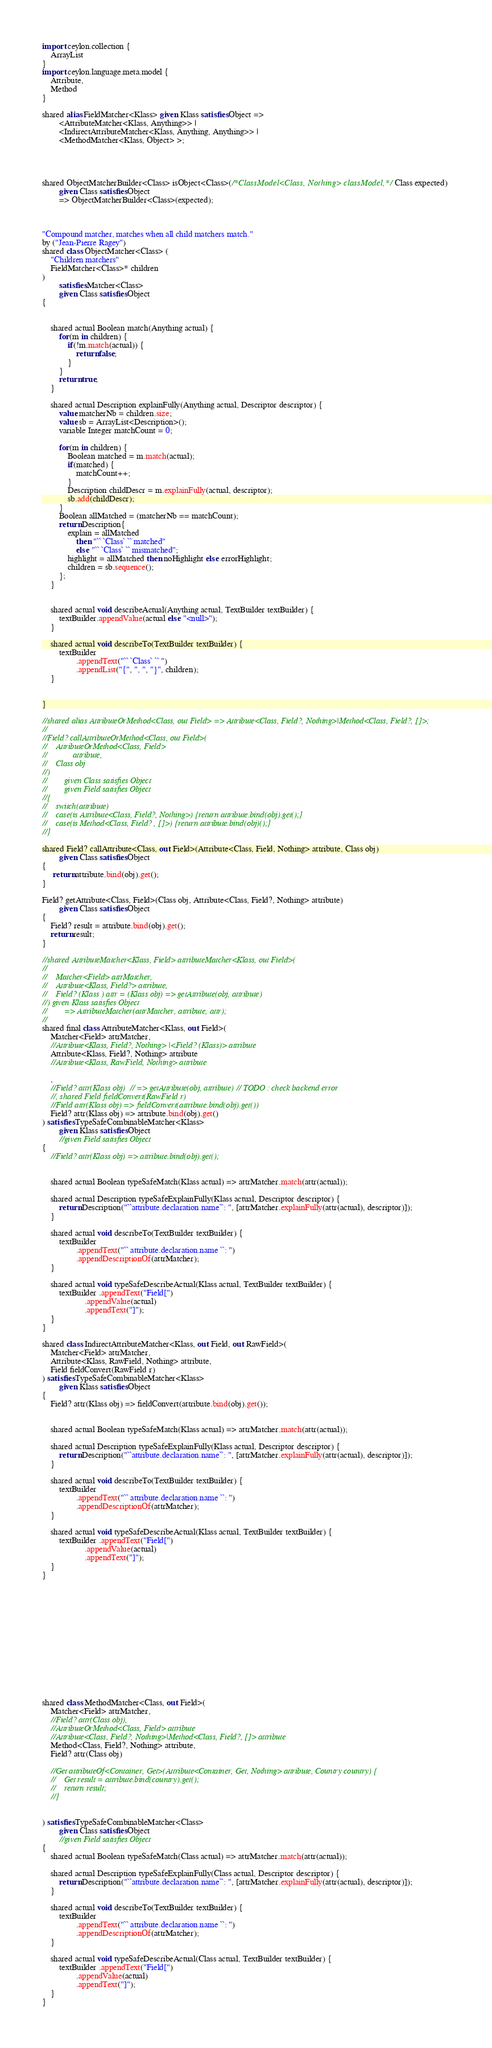Convert code to text. <code><loc_0><loc_0><loc_500><loc_500><_Ceylon_>import ceylon.collection {
	ArrayList
}
import ceylon.language.meta.model {
	Attribute,
	Method
}

shared alias FieldMatcher<Klass> given Klass satisfies Object => 
        <AttributeMatcher<Klass, Anything>> | 
        <IndirectAttributeMatcher<Klass, Anything, Anything>> | 
        <MethodMatcher<Klass, Object> >;




shared ObjectMatcherBuilder<Class> isObject<Class>(/*ClassModel<Class, Nothing> classModel,*/ Class expected) 
        given Class satisfies Object
        => ObjectMatcherBuilder<Class>(expected);



"Compound matcher, matches when all child matchers match."
by ("Jean-Pierre Ragey")
shared class ObjectMatcher<Class> (
    "Children matchers"
    FieldMatcher<Class>* children
) 
        satisfies Matcher<Class> 
        given Class satisfies Object
{
            
    
    shared actual Boolean match(Anything actual) {
        for(m in children) {
            if(!m.match(actual)) {
                return false;
            }
        }
        return true;
    }
    
    shared actual Description explainFully(Anything actual, Descriptor descriptor) {
        value matcherNb = children.size;
        value sb = ArrayList<Description>();
        variable Integer matchCount = 0;
        
        for(m in children) {
            Boolean matched = m.match(actual);
            if(matched) {
                matchCount++;
            }
            Description childDescr = m.explainFully(actual, descriptor);
            sb.add(childDescr);
        }
        Boolean allMatched = (matcherNb == matchCount);
        return Description{
            explain = allMatched
                then "`` `Class` `` matched"
                else "`` `Class` `` mismatched";
            highlight = allMatched then noHighlight else errorHighlight;
            children = sb.sequence();
        };
    }
    
    
    shared actual void describeActual(Anything actual, TextBuilder textBuilder) {
        textBuilder.appendValue(actual else "<null>");
    }
    
    shared actual void describeTo(TextBuilder textBuilder) {
        textBuilder
                .appendText("`` `Class` `` ")
                .appendList("{", ", ", "}", children);
    }
    
    
}

//shared alias AttributeOrMethod<Class, out Field> => Attribute<Class, Field?, Nothing>|Method<Class, Field?, []>;
//
//Field? callAttributeOrMethod<Class, out Field>(
//    AttributeOrMethod<Class, Field> 
//            attribute,
//    Class obj
//) 
//        given Class satisfies Object
//        given Field satisfies Object
//{
//    switch(attribute)
//    case(is Attribute<Class, Field?, Nothing>) {return attribute.bind(obj).get();}
//    case(is Method<Class, Field? , []>) {return attribute.bind(obj)();}
//}

shared Field? callAttribute<Class, out Field>(Attribute<Class, Field, Nothing> attribute, Class obj) 
        given Class satisfies Object
{
     return attribute.bind(obj).get();
}

Field? getAttribute<Class, Field>(Class obj, Attribute<Class, Field?, Nothing> attribute)
        given Class satisfies Object
{
    Field? result = attribute.bind(obj).get();
    return result;
}

//shared AttributeMatcher<Klass, Field> attributeMatcher<Klass, out Field>(
// 
//    Matcher<Field> attrMatcher, 
//    Attribute<Klass, Field?> attribute,
//    Field? (Klass ) attr = (Klass obj) => getAttribute(obj, attribute)
//) given Klass satisfies Object
//        => AttributeMatcher(attrMatcher, attribute, attr);
//
shared final class AttributeMatcher<Klass, out Field>(
    Matcher<Field> attrMatcher, 
    //Attribute<Klass, Field?, Nothing> |<Field? (Klass)> attribute
    Attribute<Klass, Field?, Nothing> attribute
    //Attribute<Klass, RawField, Nothing> attribute
    
    ,
    //Field? attr(Klass obj)  // => getAttribute(obj, attribute) // TODO : check backend error
    //, shared Field fieldConvert(RawField r)
    //Field attr(Klass obj) => fieldConvert(attribute.bind(obj).get())
    Field? attr(Klass obj) => attribute.bind(obj).get()
) satisfies TypeSafeCombinableMatcher<Klass>
        given Klass satisfies Object
        //given Field satisfies Object
{
    //Field? attr(Klass obj) => attribute.bind(obj).get();
    
    
    shared actual Boolean typeSafeMatch(Klass actual) => attrMatcher.match(attr(actual));

    shared actual Description typeSafeExplainFully(Klass actual, Descriptor descriptor) {
        return Description("``attribute.declaration.name``: ", [attrMatcher.explainFully(attr(actual), descriptor)]);
    }

    shared actual void describeTo(TextBuilder textBuilder) {
        textBuilder
                .appendText("`` attribute.declaration.name ``: ") 
                .appendDescriptionOf(attrMatcher);
    }
    
    shared actual void typeSafeDescribeActual(Klass actual, TextBuilder textBuilder) {
        textBuilder .appendText("Field[")
                    .appendValue(actual)
                    .appendText("]");
    }
}

shared class IndirectAttributeMatcher<Klass, out Field, out RawField>(
    Matcher<Field> attrMatcher, 
    Attribute<Klass, RawField, Nothing> attribute, 
    Field fieldConvert(RawField r)
) satisfies TypeSafeCombinableMatcher<Klass>
        given Klass satisfies Object
{
    Field? attr(Klass obj) => fieldConvert(attribute.bind(obj).get());
    
    
    shared actual Boolean typeSafeMatch(Klass actual) => attrMatcher.match(attr(actual));

    shared actual Description typeSafeExplainFully(Klass actual, Descriptor descriptor) {
        return Description("``attribute.declaration.name``: ", [attrMatcher.explainFully(attr(actual), descriptor)]);
    }

    shared actual void describeTo(TextBuilder textBuilder) {
        textBuilder
                .appendText("`` attribute.declaration.name ``: ") 
                .appendDescriptionOf(attrMatcher);
    }
    
    shared actual void typeSafeDescribeActual(Klass actual, TextBuilder textBuilder) {
        textBuilder .appendText("Field[")
                    .appendValue(actual)
                    .appendText("]");
    }
}














shared class MethodMatcher<Class, out Field>(
    Matcher<Field> attrMatcher, 
    //Field? attr(Class obj),
    //AttributeOrMethod<Class, Field> attribute
    //Attribute<Class, Field?, Nothing>|Method<Class, Field?, []> attribute
    Method<Class, Field?, Nothing> attribute,
    Field? attr(Class obj)
    
    //Get attributeOf<Container, Get>(Attribute<Container, Get, Nothing> attribute, Country country) {
    //    Get result = attribute.bind(country).get();
    //    return result;
    //}
    
    
) satisfies TypeSafeCombinableMatcher<Class>
        given Class satisfies Object
        //given Field satisfies Object
{
    shared actual Boolean typeSafeMatch(Class actual) => attrMatcher.match(attr(actual));
    
    shared actual Description typeSafeExplainFully(Class actual, Descriptor descriptor) {
        return Description("``attribute.declaration.name``: ", [attrMatcher.explainFully(attr(actual), descriptor)]);
    }
    
    shared actual void describeTo(TextBuilder textBuilder) {
        textBuilder
                .appendText("`` attribute.declaration.name ``: ") 
                .appendDescriptionOf(attrMatcher);
    }
    
    shared actual void typeSafeDescribeActual(Class actual, TextBuilder textBuilder) {
        textBuilder .appendText("Field[")
                .appendValue(actual)
                .appendText("]");
    }
}
</code> 